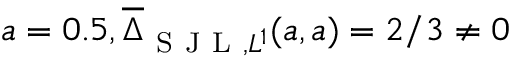<formula> <loc_0><loc_0><loc_500><loc_500>a = 0 . 5 , \overline { \Delta } _ { S J L , L ^ { 1 } } ( a , a ) = 2 / 3 \neq 0</formula> 